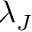Convert formula to latex. <formula><loc_0><loc_0><loc_500><loc_500>\lambda _ { J }</formula> 